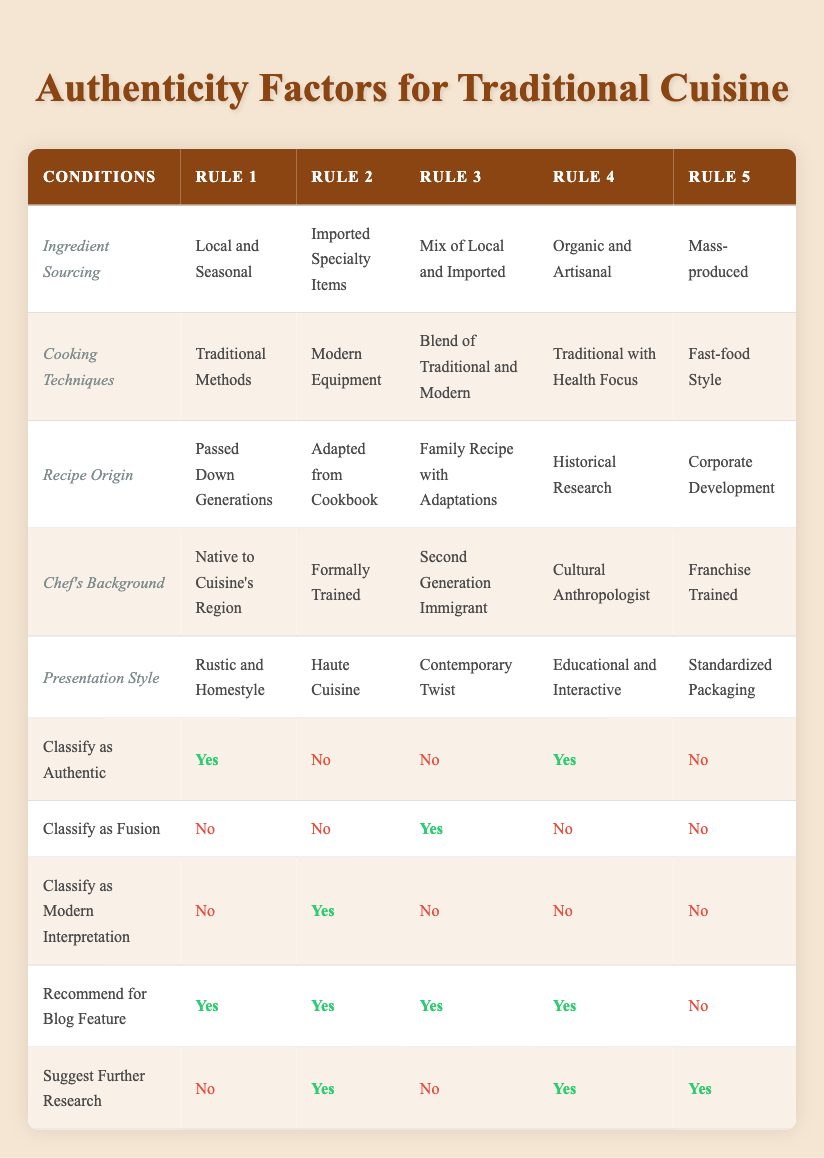What types of ingredient sourcing classify as authentic? According to the table, ingredient sourcing classified as authentic includes "Local and Seasonal" and "Organic and Artisanal".
Answer: Local and Seasonal, Organic and Artisanal How many rules classify cuisine as fusion? The table shows that Rule 3 ("Mix of Local and Imported") classifies the dish as fusion, while Rules 2 and 5 classify it as no fusion. Thus, there is only one rule that classifies as fusion.
Answer: 1 Is fast-food style cooking techniques classified as authentic? The table indicates that fast-food style is classified as no for authenticity, found in Rule 5 under cooking techniques.
Answer: No Which presentation style is recommended for blog feature in the highest number of rules? All rules recommend for a blog feature, except Rule 5 (mass-produced), which recommends no. Therefore, four rules recommend the blog feature, showing no variation in this aspect.
Answer: 4 Are cuisines with a chef's background as "Cultural Anthropologist" classified as authentic? The table states that a chef's background as a cultural anthropologist is classified as authentic as per Rule 4, where it shows "Yes."
Answer: Yes How many types of cooking techniques classify as modern interpretation? The table shows that only Rule 2 ("Modern Equipment") classifies cooking techniques as a modern interpretation, while other rules either result in "No" or are categorized as "Authentic".
Answer: 1 What is the recipe origin for a cuisine that uses imported specialty items? According to Rule 2, the recipe origin for cuisine that uses imported specialty items is "Adapted from Cookbook".
Answer: Adapted from Cookbook Does a chef's background being "Franchise Trained" affect the classification of authenticity? Yes, the table shows that a chef's background as "Franchise Trained" leads to a classification of no for authenticity in Rule 5.
Answer: Yes What is the relationship between educational presentation style and the authenticity classification? The table shows that the "Educational and Interactive" presentation style in Rule 4 is classified as authentic. This means that such a presentation enhances authenticity classification.
Answer: Enhances authenticity classification 